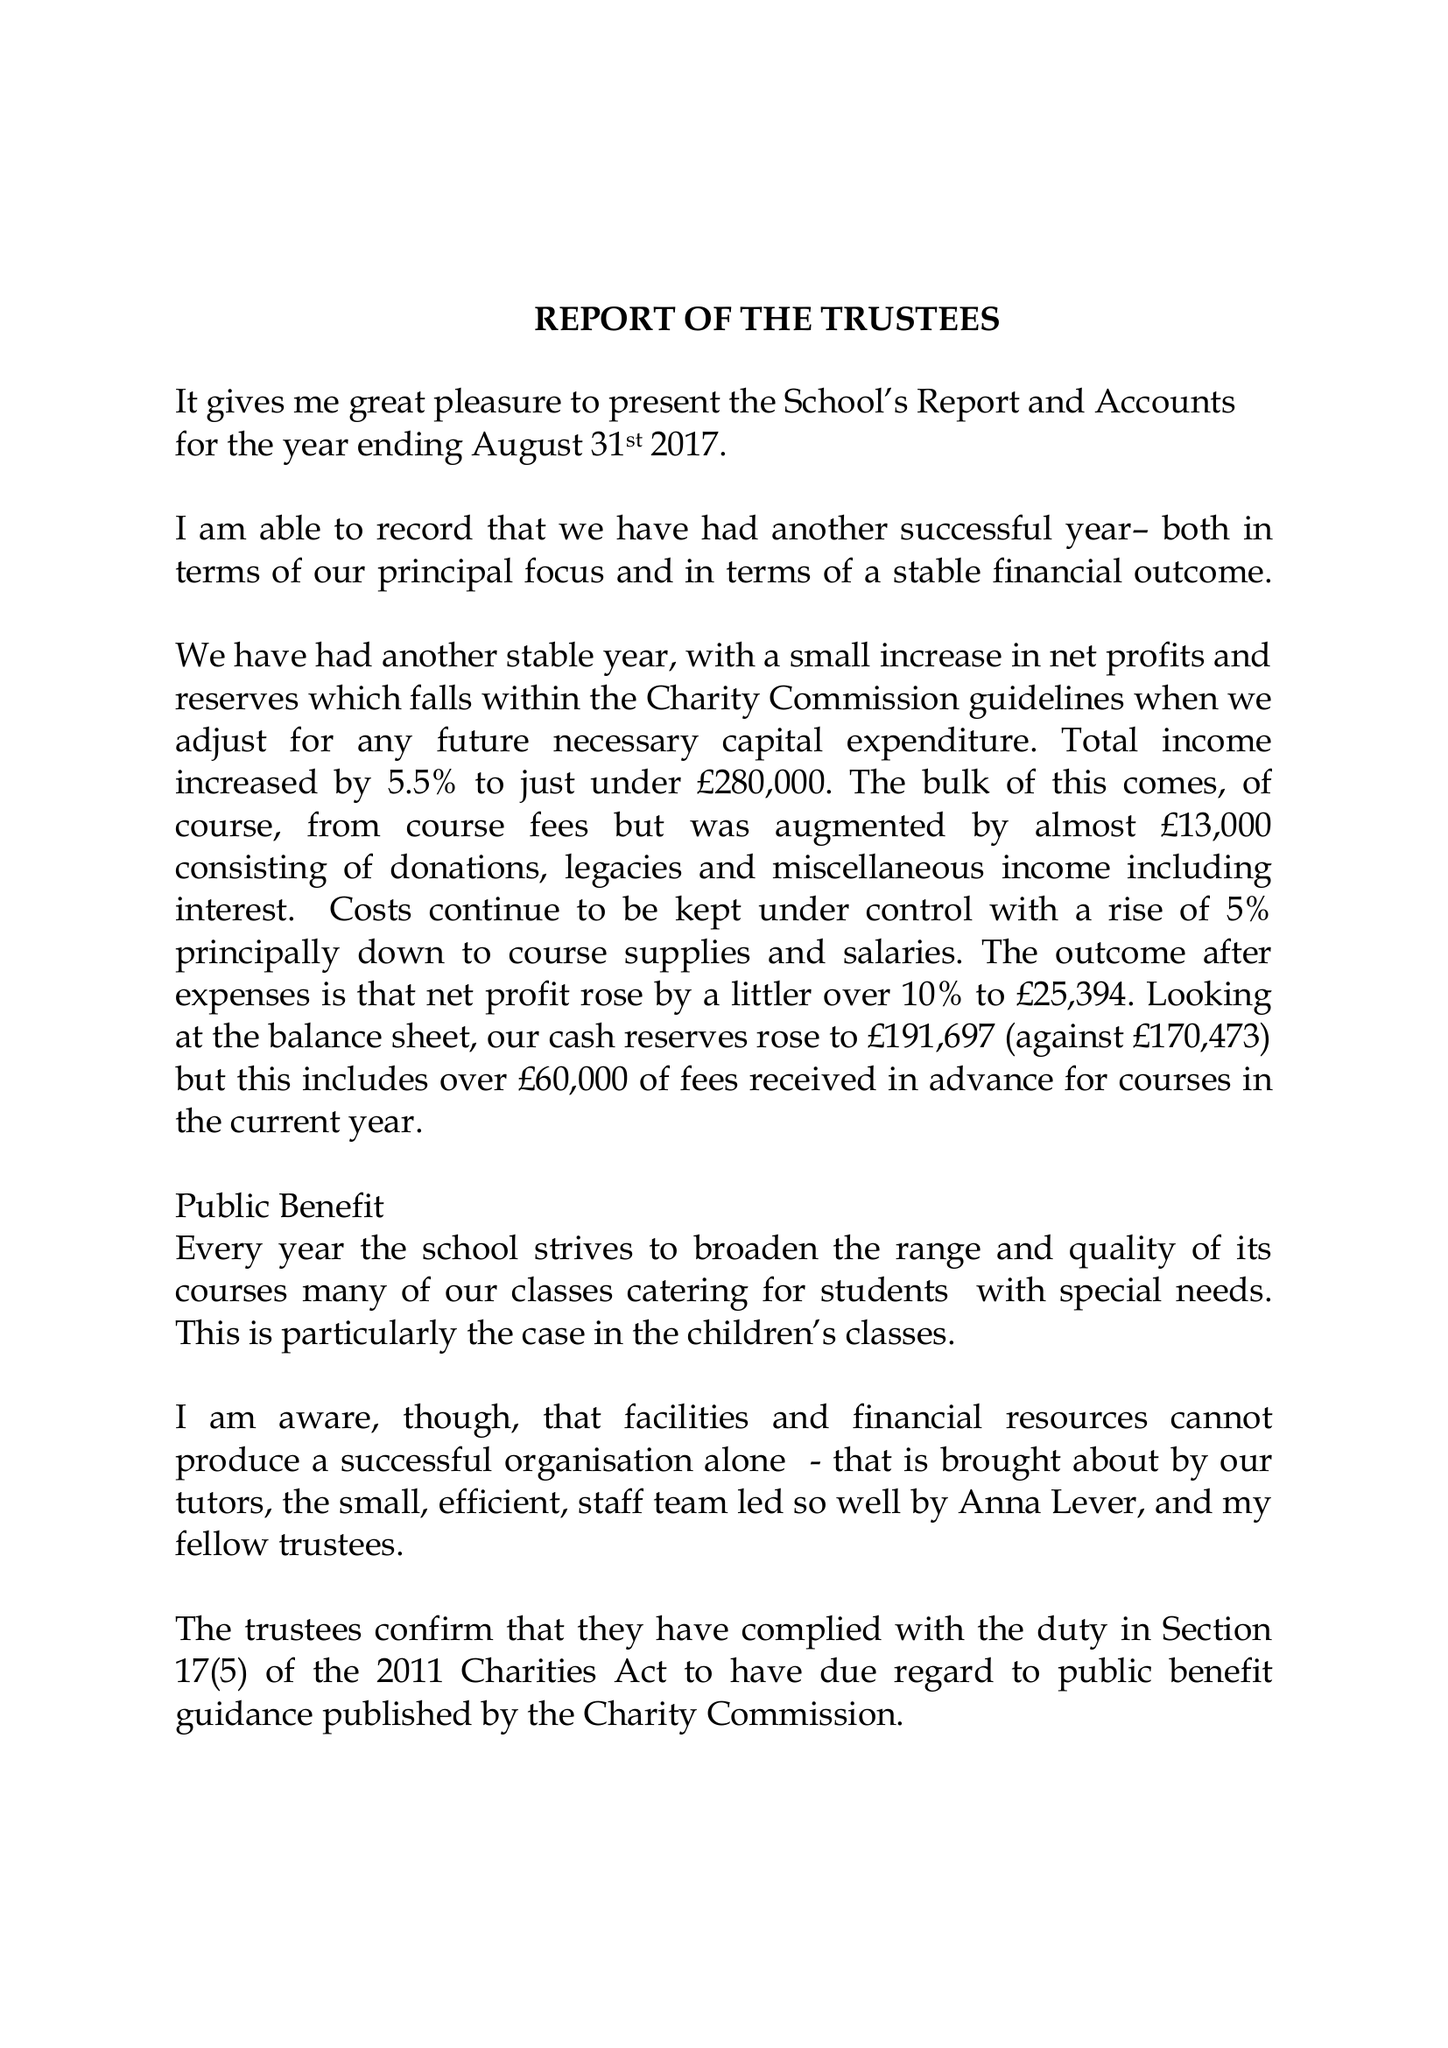What is the value for the address__post_town?
Answer the question using a single word or phrase. ABINGDON 